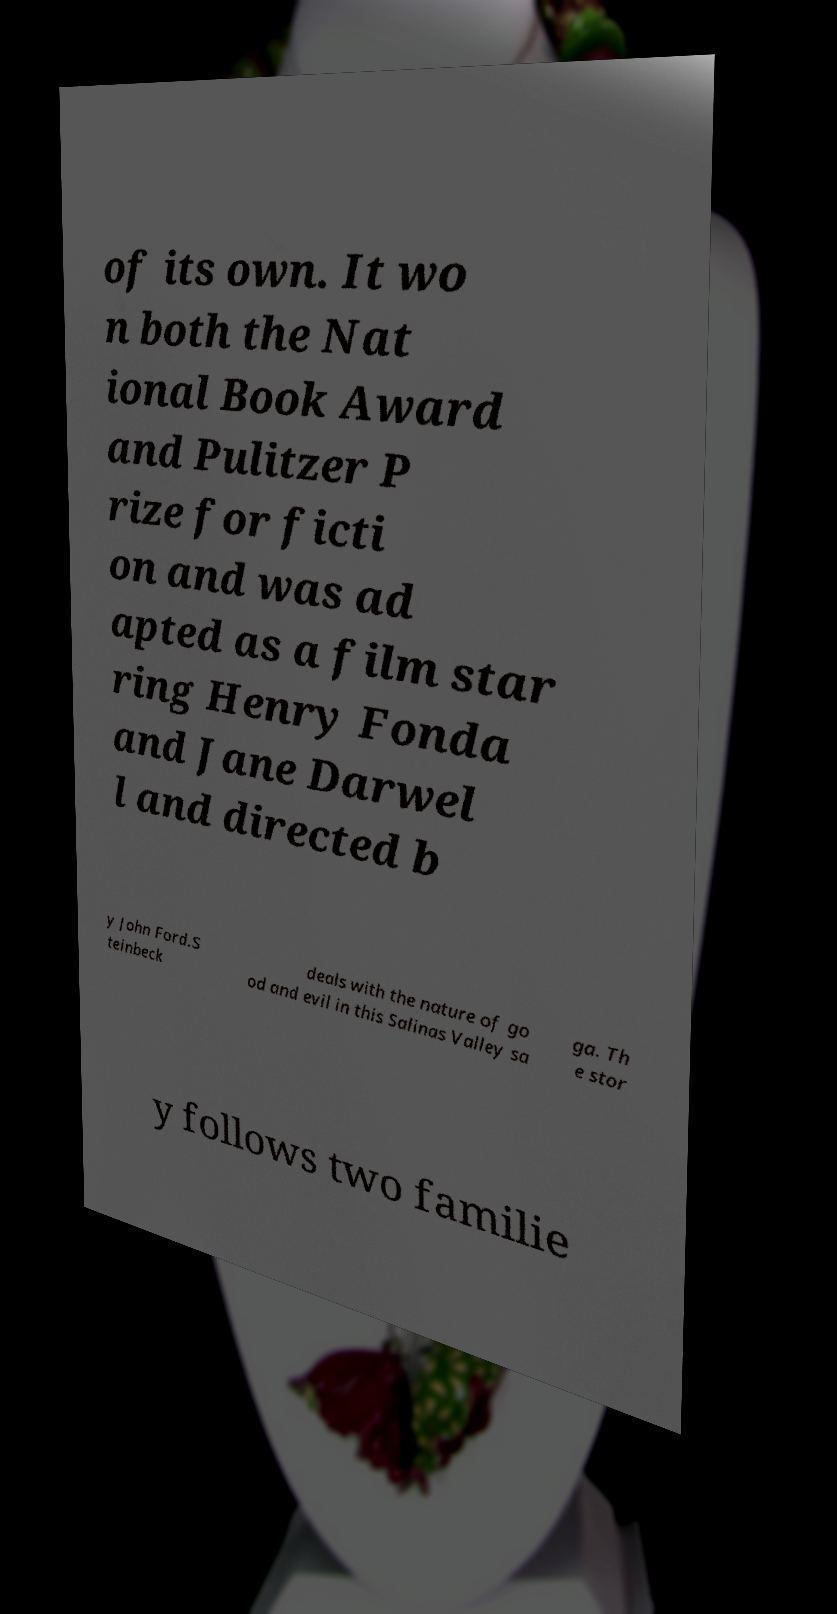There's text embedded in this image that I need extracted. Can you transcribe it verbatim? of its own. It wo n both the Nat ional Book Award and Pulitzer P rize for ficti on and was ad apted as a film star ring Henry Fonda and Jane Darwel l and directed b y John Ford.S teinbeck deals with the nature of go od and evil in this Salinas Valley sa ga. Th e stor y follows two familie 